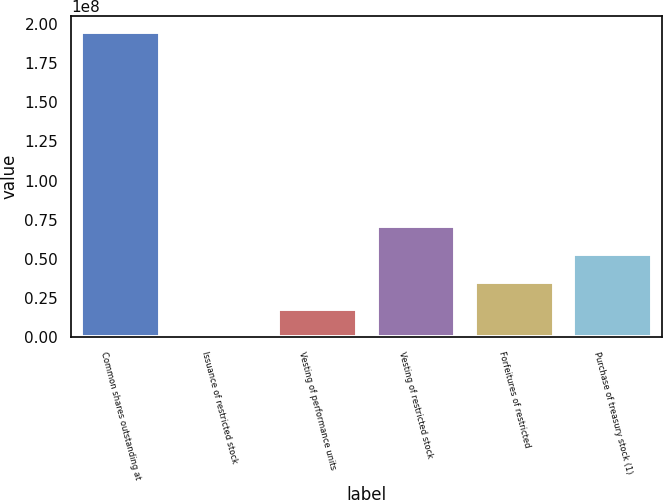<chart> <loc_0><loc_0><loc_500><loc_500><bar_chart><fcel>Common shares outstanding at<fcel>Issuance of restricted stock<fcel>Vesting of performance units<fcel>Vesting of restricted stock<fcel>Forfeitures of restricted<fcel>Purchase of treasury stock (1)<nl><fcel>1.9508e+08<fcel>55626<fcel>1.77908e+07<fcel>7.09964e+07<fcel>3.5526e+07<fcel>5.32612e+07<nl></chart> 